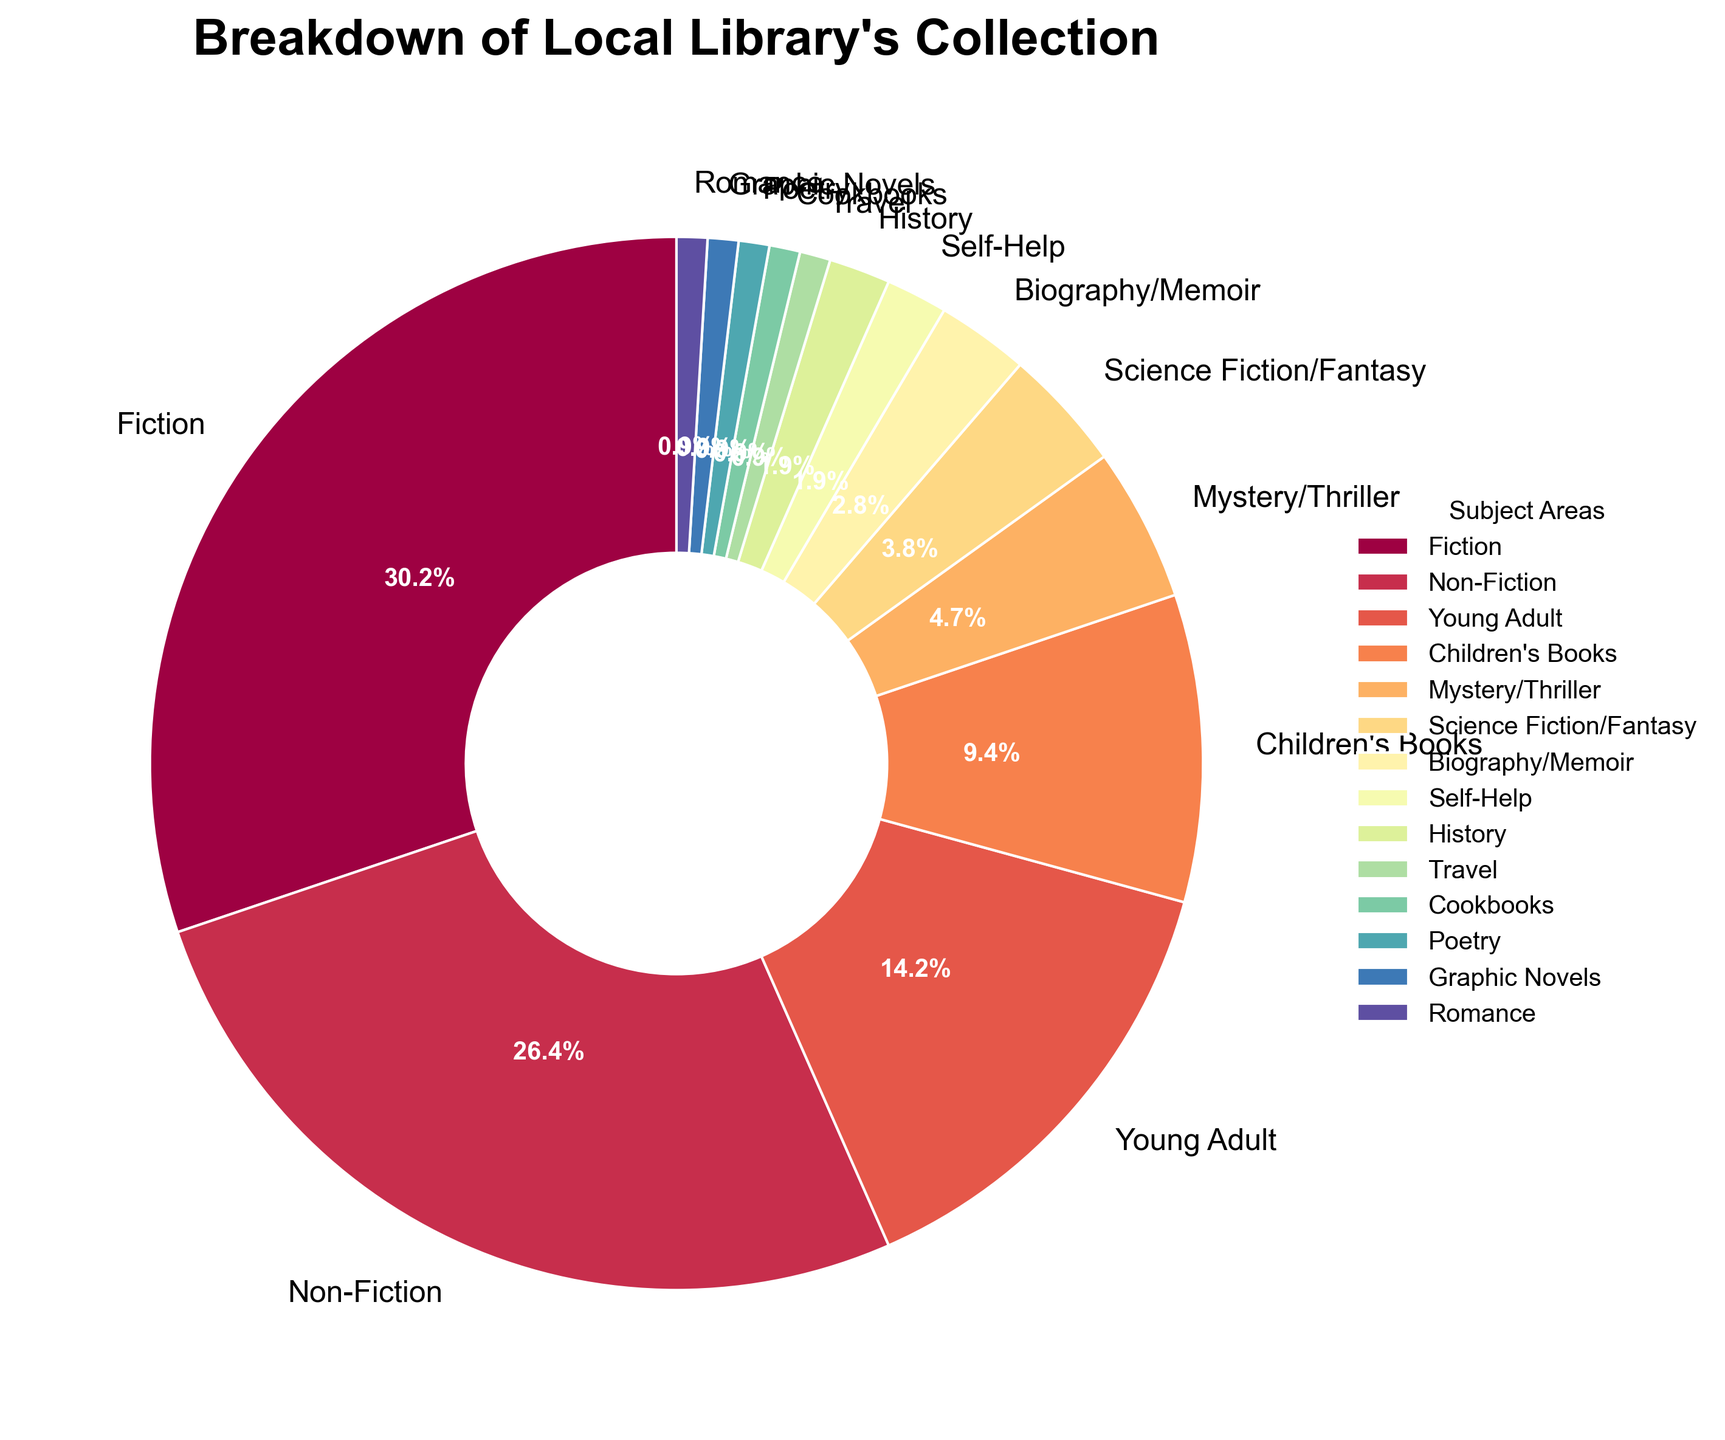Which subject area has the highest percentage of books? By referring to the figure, we can see that the largest wedge in the pie chart corresponds to the subject area "Fiction." The label indicates that Fiction has a percentage of 32%, which is the highest among all the subject areas.
Answer: Fiction How much higher is the percentage of Fiction books compared to Non-Fiction books? Fiction has 32% while Non-Fiction has 28%. The difference in percentage points is calculated as 32% - 28% = 4%.
Answer: 4% What is the total percentage of books in the Young Adult, Children's Books, and Mystery/Thriller categories combined? The Young Adult category has 15%, Children's Books have 10%, and Mystery/Thriller has 5%. Adding these together gives 15% + 10% + 5% = 30%.
Answer: 30% Which subject areas have the same percentage of books in the collection? By reviewing the figure, we observe that the categories History, Travel, Cookbooks, Poetry, Graphic Novels, and Romance all have 1% each.
Answer: History, Travel, Cookbooks, Poetry, Graphic Novels, Romance Which category is represented by the smallest wedge in the pie chart? The figural representation shows multiple categories with the smallest wedge (1%). From the legend, the categories with 1% are History, Travel, Cookbooks, Poetry, Graphic Novels, and Romance.
Answer: History, Travel, Cookbooks, Poetry, Graphic Novels, Romance What is the percentage difference between the highest and the lowest subject areas? The highest percentage is Fiction with 32%, and the lowest percentage is shared by several categories (History, Travel, Cookbooks, Poetry, Graphic Novels, Romance) at 1%. The difference is calculated as 32% - 1% = 31%.
Answer: 31% What can you infer about the diversity of subjects in the library's collection based on the pie chart? The pie chart shows a wide range of subject areas, with Fiction being the most prevalent at 32%. However, there are numerous subject areas that each account for only 1% of the collection, indicating a broad but uneven distribution across subjects.
Answer: Broad but uneven distribution 